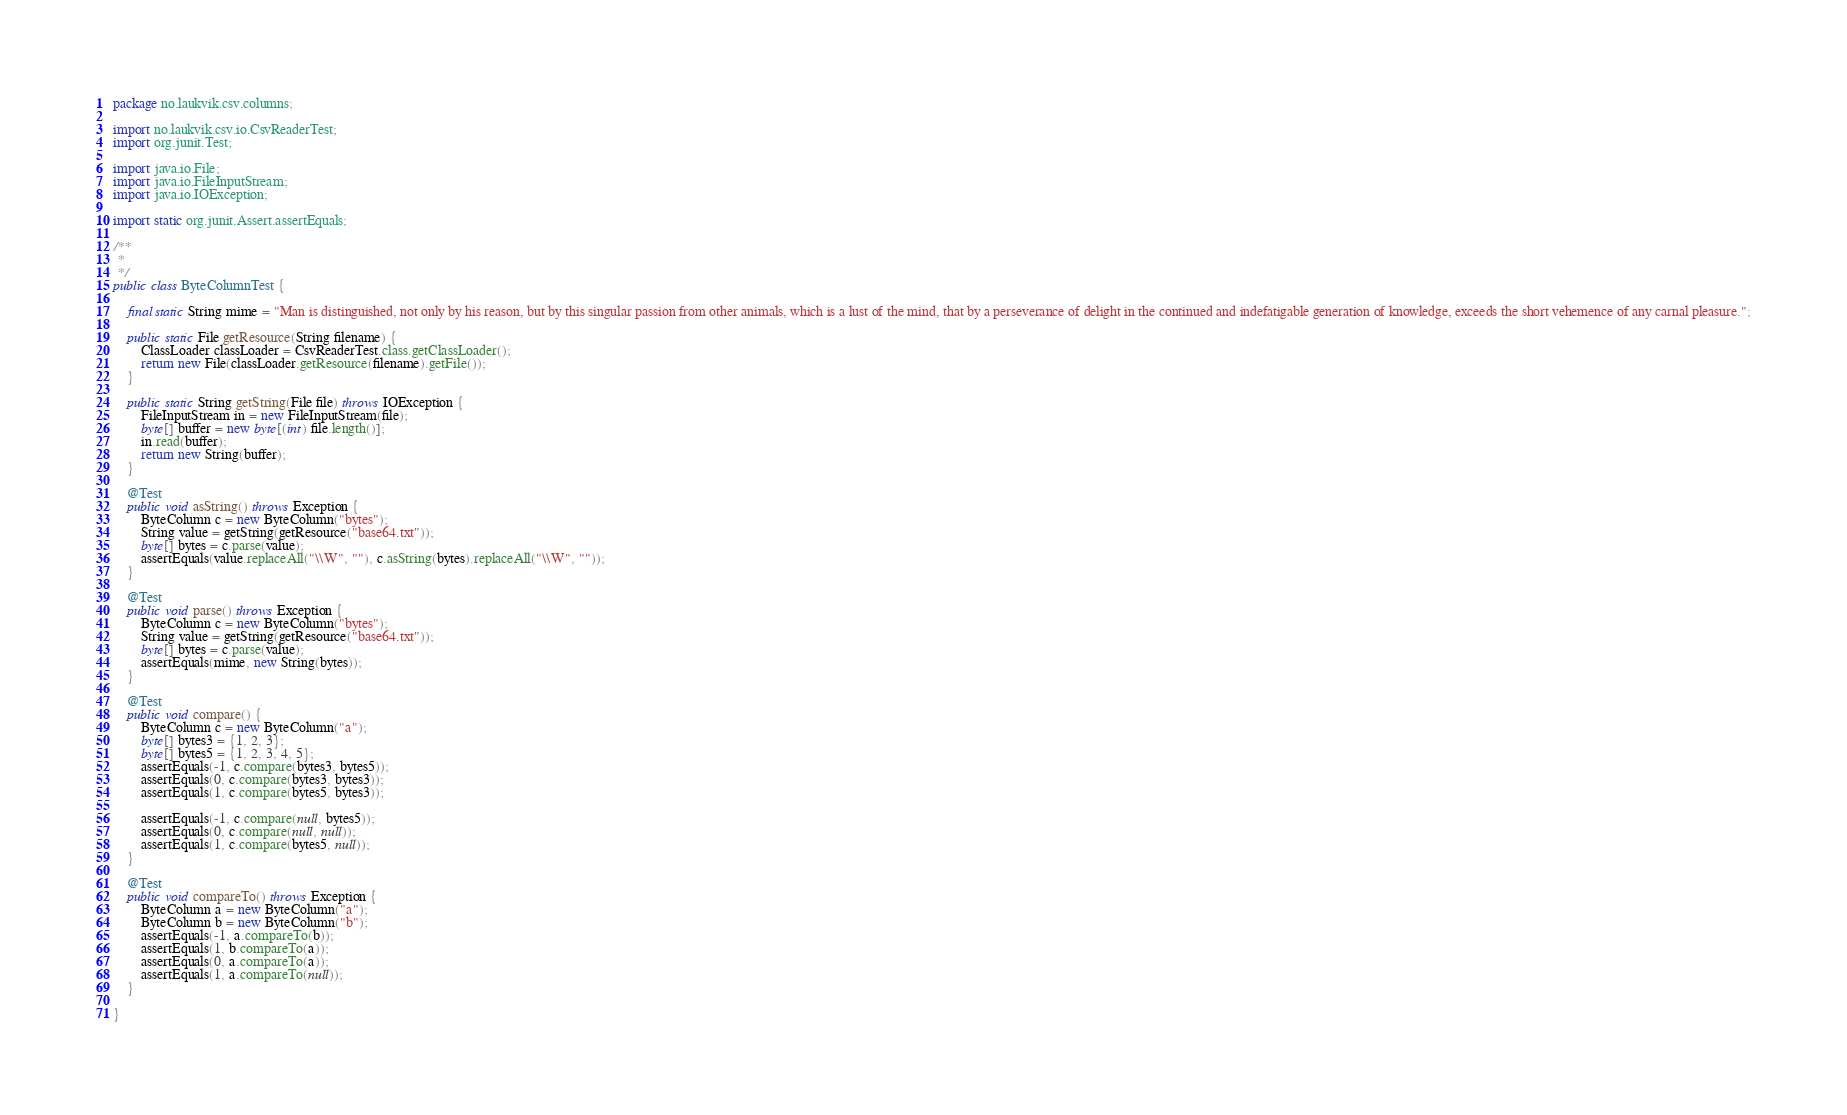<code> <loc_0><loc_0><loc_500><loc_500><_Java_>package no.laukvik.csv.columns;

import no.laukvik.csv.io.CsvReaderTest;
import org.junit.Test;

import java.io.File;
import java.io.FileInputStream;
import java.io.IOException;

import static org.junit.Assert.assertEquals;

/**
 *
 */
public class ByteColumnTest {

    final static String mime = "Man is distinguished, not only by his reason, but by this singular passion from other animals, which is a lust of the mind, that by a perseverance of delight in the continued and indefatigable generation of knowledge, exceeds the short vehemence of any carnal pleasure.";

    public static File getResource(String filename) {
        ClassLoader classLoader = CsvReaderTest.class.getClassLoader();
        return new File(classLoader.getResource(filename).getFile());
    }

    public static String getString(File file) throws IOException {
        FileInputStream in = new FileInputStream(file);
        byte[] buffer = new byte[(int) file.length()];
        in.read(buffer);
        return new String(buffer);
    }

    @Test
    public void asString() throws Exception {
        ByteColumn c = new ByteColumn("bytes");
        String value = getString(getResource("base64.txt"));
        byte[] bytes = c.parse(value);
        assertEquals(value.replaceAll("\\W", ""), c.asString(bytes).replaceAll("\\W", ""));
    }

    @Test
    public void parse() throws Exception {
        ByteColumn c = new ByteColumn("bytes");
        String value = getString(getResource("base64.txt"));
        byte[] bytes = c.parse(value);
        assertEquals(mime, new String(bytes));
    }

    @Test
    public void compare() {
        ByteColumn c = new ByteColumn("a");
        byte[] bytes3 = {1, 2, 3};
        byte[] bytes5 = {1, 2, 3, 4, 5};
        assertEquals(-1, c.compare(bytes3, bytes5));
        assertEquals(0, c.compare(bytes3, bytes3));
        assertEquals(1, c.compare(bytes5, bytes3));

        assertEquals(-1, c.compare(null, bytes5));
        assertEquals(0, c.compare(null, null));
        assertEquals(1, c.compare(bytes5, null));
    }

    @Test
    public void compareTo() throws Exception {
        ByteColumn a = new ByteColumn("a");
        ByteColumn b = new ByteColumn("b");
        assertEquals(-1, a.compareTo(b));
        assertEquals(1, b.compareTo(a));
        assertEquals(0, a.compareTo(a));
        assertEquals(1, a.compareTo(null));
    }

}</code> 